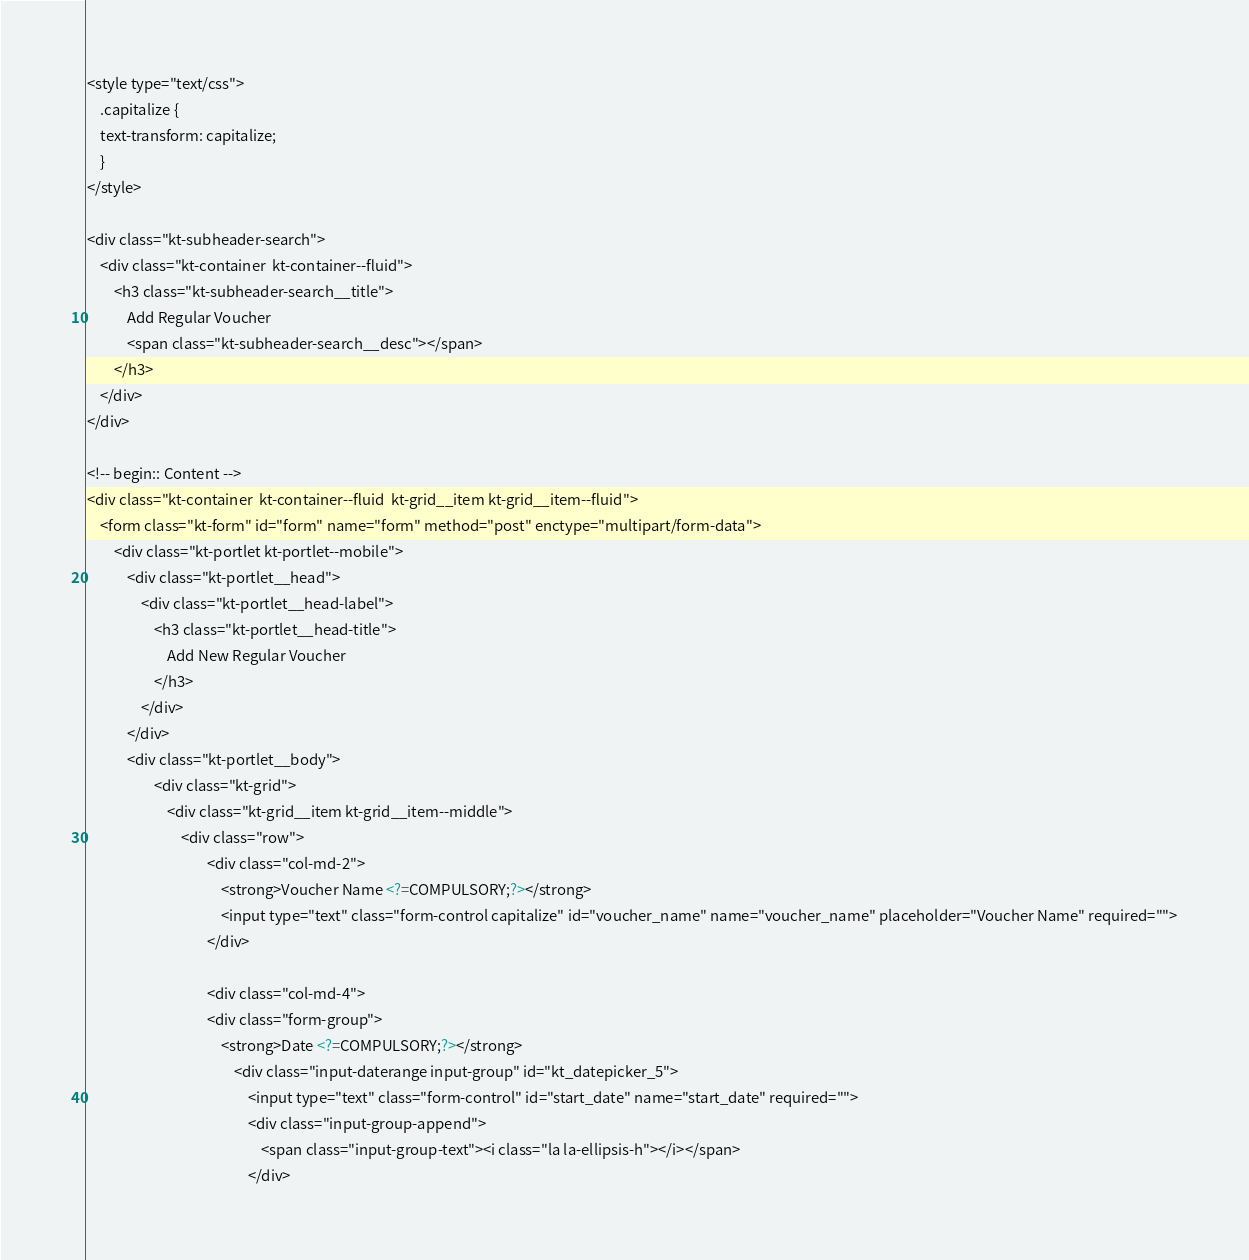Convert code to text. <code><loc_0><loc_0><loc_500><loc_500><_PHP_><style type="text/css">
	.capitalize {
  	text-transform: capitalize;
	}
</style>

<div class="kt-subheader-search">
	<div class="kt-container  kt-container--fluid">
		<h3 class="kt-subheader-search__title">
			Add Regular Voucher
			<span class="kt-subheader-search__desc"></span>
		</h3>
	</div>
</div>

<!-- begin:: Content -->
<div class="kt-container  kt-container--fluid  kt-grid__item kt-grid__item--fluid">
	<form class="kt-form" id="form" name="form" method="post" enctype="multipart/form-data">
		<div class="kt-portlet kt-portlet--mobile">
			<div class="kt-portlet__head">
				<div class="kt-portlet__head-label">
					<h3 class="kt-portlet__head-title">
						Add New Regular Voucher
					</h3>
				</div>
			</div>
			<div class="kt-portlet__body">
					<div class="kt-grid">
	            		<div class="kt-grid__item kt-grid__item--middle">
		                    <div class="row">
				            		<div class="col-md-2">
										<strong>Voucher Name <?=COMPULSORY;?></strong>
										<input type="text" class="form-control capitalize" id="voucher_name" name="voucher_name" placeholder="Voucher Name" required="">
									</div>
									
									<div class="col-md-4">
			                        <div class="form-group">
			                            <strong>Date <?=COMPULSORY;?></strong>
					                        <div class="input-daterange input-group" id="kt_datepicker_5">
												<input type="text" class="form-control" id="start_date" name="start_date" required="">
												<div class="input-group-append">
													<span class="input-group-text"><i class="la la-ellipsis-h"></i></span>
												</div></code> 